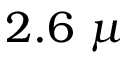<formula> <loc_0><loc_0><loc_500><loc_500>2 . 6 \ \mu</formula> 